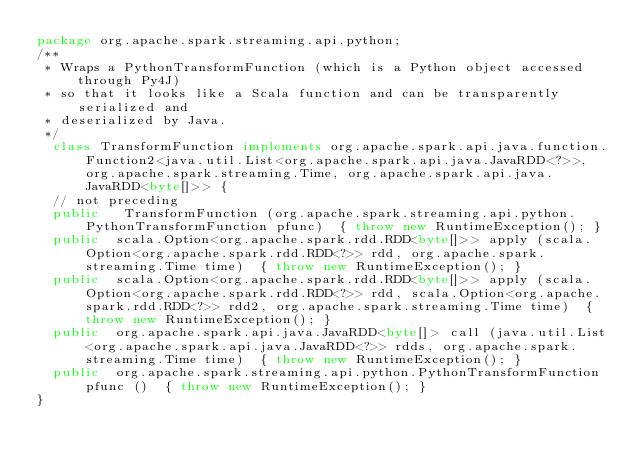Convert code to text. <code><loc_0><loc_0><loc_500><loc_500><_Java_>package org.apache.spark.streaming.api.python;
/**
 * Wraps a PythonTransformFunction (which is a Python object accessed through Py4J)
 * so that it looks like a Scala function and can be transparently serialized and
 * deserialized by Java.
 */
  class TransformFunction implements org.apache.spark.api.java.function.Function2<java.util.List<org.apache.spark.api.java.JavaRDD<?>>, org.apache.spark.streaming.Time, org.apache.spark.api.java.JavaRDD<byte[]>> {
  // not preceding
  public   TransformFunction (org.apache.spark.streaming.api.python.PythonTransformFunction pfunc)  { throw new RuntimeException(); }
  public  scala.Option<org.apache.spark.rdd.RDD<byte[]>> apply (scala.Option<org.apache.spark.rdd.RDD<?>> rdd, org.apache.spark.streaming.Time time)  { throw new RuntimeException(); }
  public  scala.Option<org.apache.spark.rdd.RDD<byte[]>> apply (scala.Option<org.apache.spark.rdd.RDD<?>> rdd, scala.Option<org.apache.spark.rdd.RDD<?>> rdd2, org.apache.spark.streaming.Time time)  { throw new RuntimeException(); }
  public  org.apache.spark.api.java.JavaRDD<byte[]> call (java.util.List<org.apache.spark.api.java.JavaRDD<?>> rdds, org.apache.spark.streaming.Time time)  { throw new RuntimeException(); }
  public  org.apache.spark.streaming.api.python.PythonTransformFunction pfunc ()  { throw new RuntimeException(); }
}
</code> 